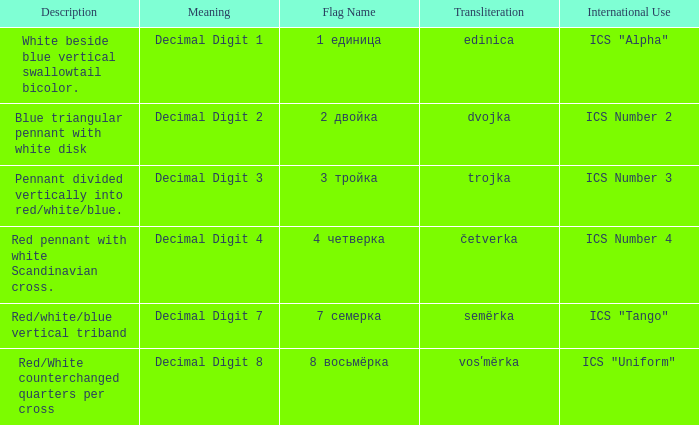What are the meanings of the flag whose name transliterates to dvojka? Decimal Digit 2. 